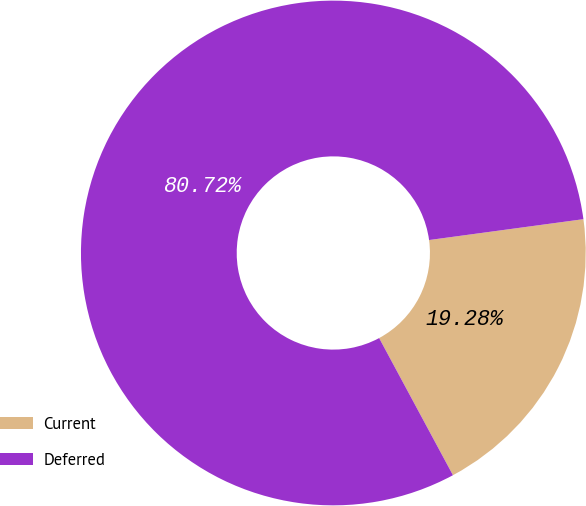Convert chart to OTSL. <chart><loc_0><loc_0><loc_500><loc_500><pie_chart><fcel>Current<fcel>Deferred<nl><fcel>19.28%<fcel>80.72%<nl></chart> 